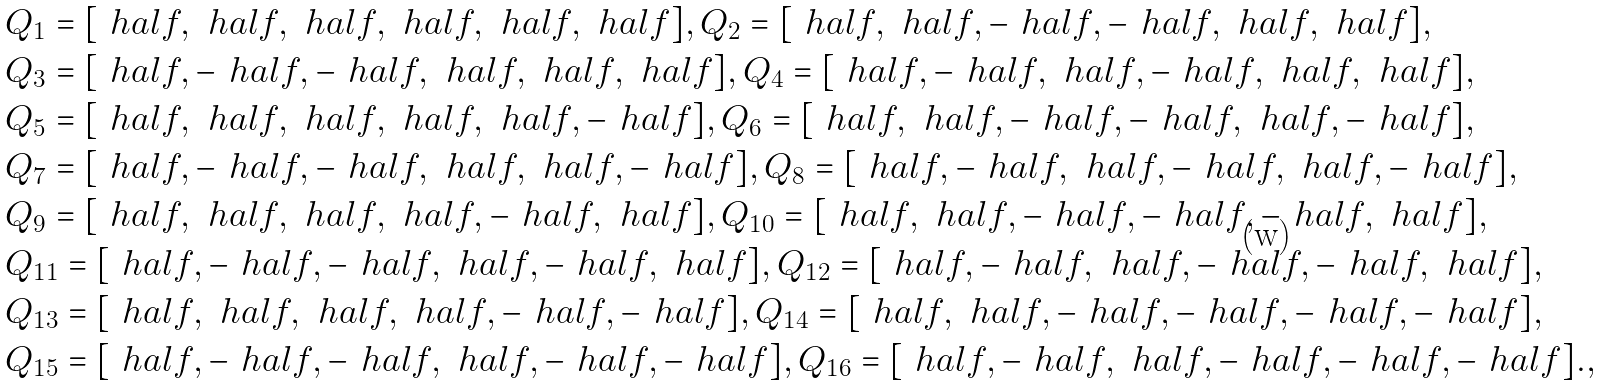<formula> <loc_0><loc_0><loc_500><loc_500>& Q _ { 1 } = [ \ h a l f , \ h a l f , \ h a l f , \ h a l f , \ h a l f , \ h a l f ] , Q _ { 2 } = [ \ h a l f , \ h a l f , - \ h a l f , - \ h a l f , \ h a l f , \ h a l f ] , \\ & Q _ { 3 } = [ \ h a l f , - \ h a l f , - \ h a l f , \ h a l f , \ h a l f , \ h a l f ] , Q _ { 4 } = [ \ h a l f , - \ h a l f , \ h a l f , - \ h a l f , \ h a l f , \ h a l f ] , \\ & Q _ { 5 } = [ \ h a l f , \ h a l f , \ h a l f , \ h a l f , \ h a l f , - \ h a l f ] , Q _ { 6 } = [ \ h a l f , \ h a l f , - \ h a l f , - \ h a l f , \ h a l f , - \ h a l f ] , \\ & Q _ { 7 } = [ \ h a l f , - \ h a l f , - \ h a l f , \ h a l f , \ h a l f , - \ h a l f ] , Q _ { 8 } = [ \ h a l f , - \ h a l f , \ h a l f , - \ h a l f , \ h a l f , - \ h a l f ] , \\ & Q _ { 9 } = [ \ h a l f , \ h a l f , \ h a l f , \ h a l f , - \ h a l f , \ h a l f ] , Q _ { 1 0 } = [ \ h a l f , \ h a l f , - \ h a l f , - \ h a l f , - \ h a l f , \ h a l f ] , \\ & Q _ { 1 1 } = [ \ h a l f , - \ h a l f , - \ h a l f , \ h a l f , - \ h a l f , \ h a l f ] , Q _ { 1 2 } = [ \ h a l f , - \ h a l f , \ h a l f , - \ h a l f , - \ h a l f , \ h a l f ] , \\ & Q _ { 1 3 } = [ \ h a l f , \ h a l f , \ h a l f , \ h a l f , - \ h a l f , - \ h a l f ] , Q _ { 1 4 } = [ \ h a l f , \ h a l f , - \ h a l f , - \ h a l f , - \ h a l f , - \ h a l f ] , \\ & Q _ { 1 5 } = [ \ h a l f , - \ h a l f , - \ h a l f , \ h a l f , - \ h a l f , - \ h a l f ] , Q _ { 1 6 } = [ \ h a l f , - \ h a l f , \ h a l f , - \ h a l f , - \ h a l f , - \ h a l f ] . ,</formula> 